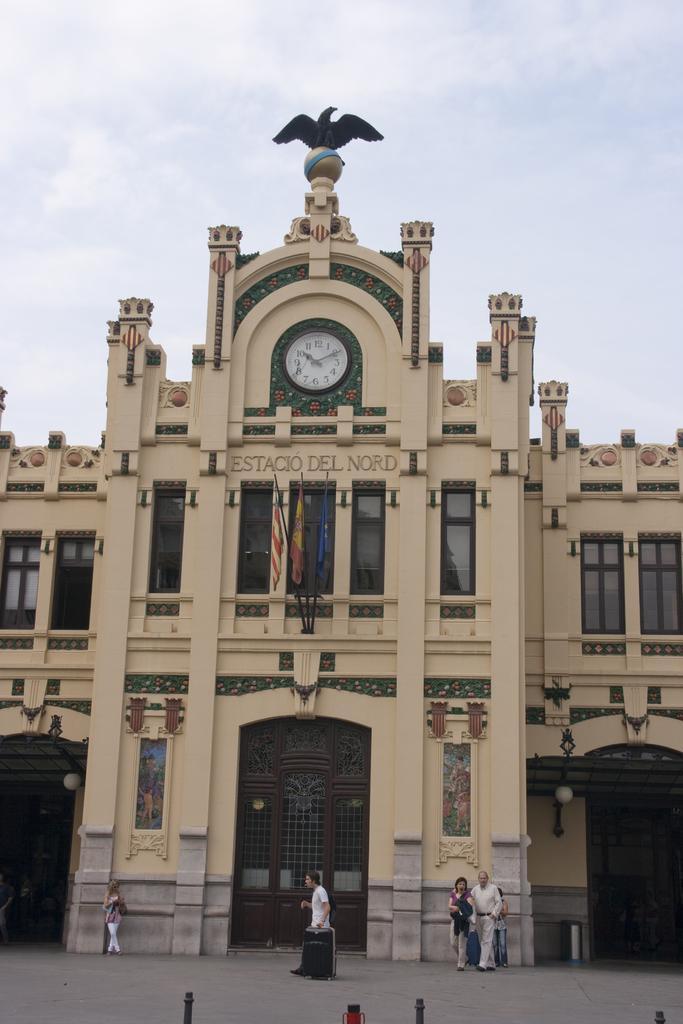What structures can be seen in the image? There are poles in the image. What else can be seen on the ground in the image? There are people on the ground in the image. What is attached to the poles in the image? There are flags in the image. What time-related object is present in the image? There is a clock in the image. What type of building is visible in the image? There is a building with windows in the image. What else can be seen in the image besides the structures and people? There are objects in the image. What can be seen in the background of the image? The sky is visible in the background of the image. What type of poisonous insect can be seen crawling on the clock in the image? There is no insect, poisonous or otherwise, present on the clock in the image. 